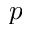Convert formula to latex. <formula><loc_0><loc_0><loc_500><loc_500>p</formula> 